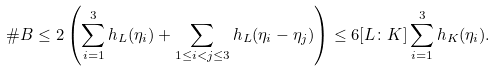Convert formula to latex. <formula><loc_0><loc_0><loc_500><loc_500>\# B \leq 2 \left ( \sum _ { i = 1 } ^ { 3 } h _ { L } ( \eta _ { i } ) + \sum _ { 1 \leq i < j \leq 3 } h _ { L } ( \eta _ { i } - \eta _ { j } ) \right ) \leq 6 [ L \colon K ] \sum _ { i = 1 } ^ { 3 } h _ { K } ( \eta _ { i } ) .</formula> 